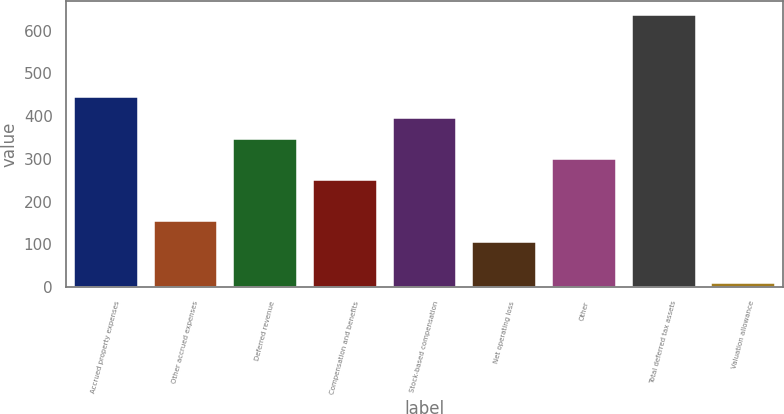Convert chart to OTSL. <chart><loc_0><loc_0><loc_500><loc_500><bar_chart><fcel>Accrued property expenses<fcel>Other accrued expenses<fcel>Deferred revenue<fcel>Compensation and benefits<fcel>Stock-based compensation<fcel>Net operating loss<fcel>Other<fcel>Total deferred tax assets<fcel>Valuation allowance<nl><fcel>443.7<fcel>153.9<fcel>347.1<fcel>250.5<fcel>395.4<fcel>105.6<fcel>298.8<fcel>636.9<fcel>9<nl></chart> 